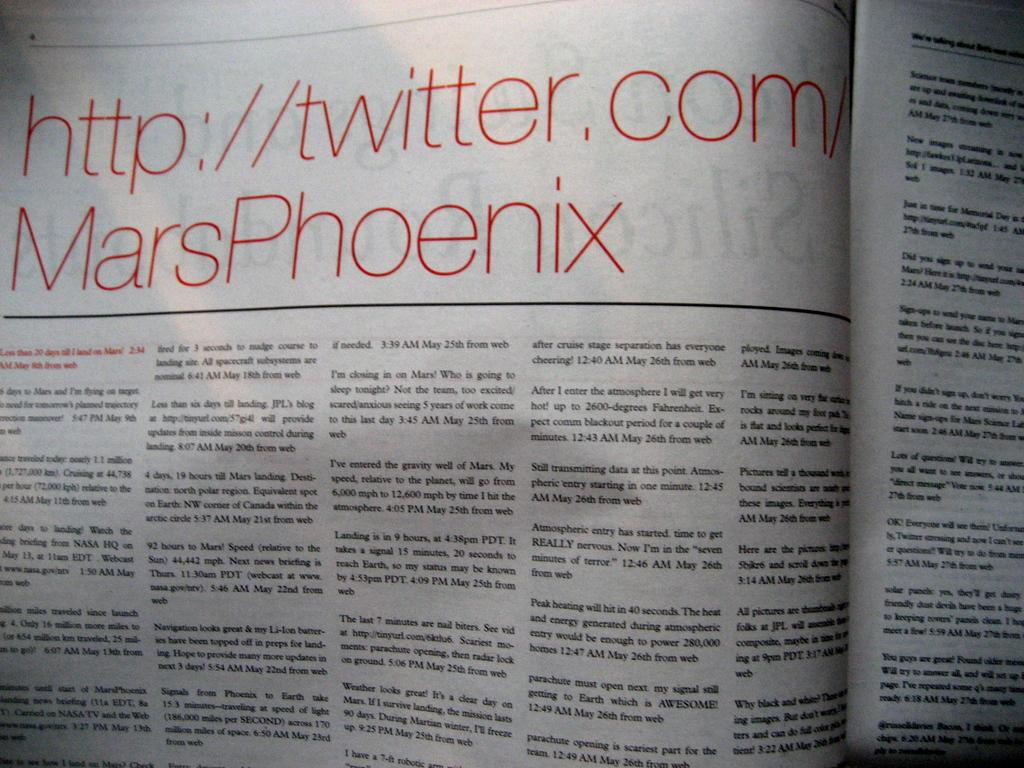<image>
Summarize the visual content of the image. The twitter account was published in the newspaper. 